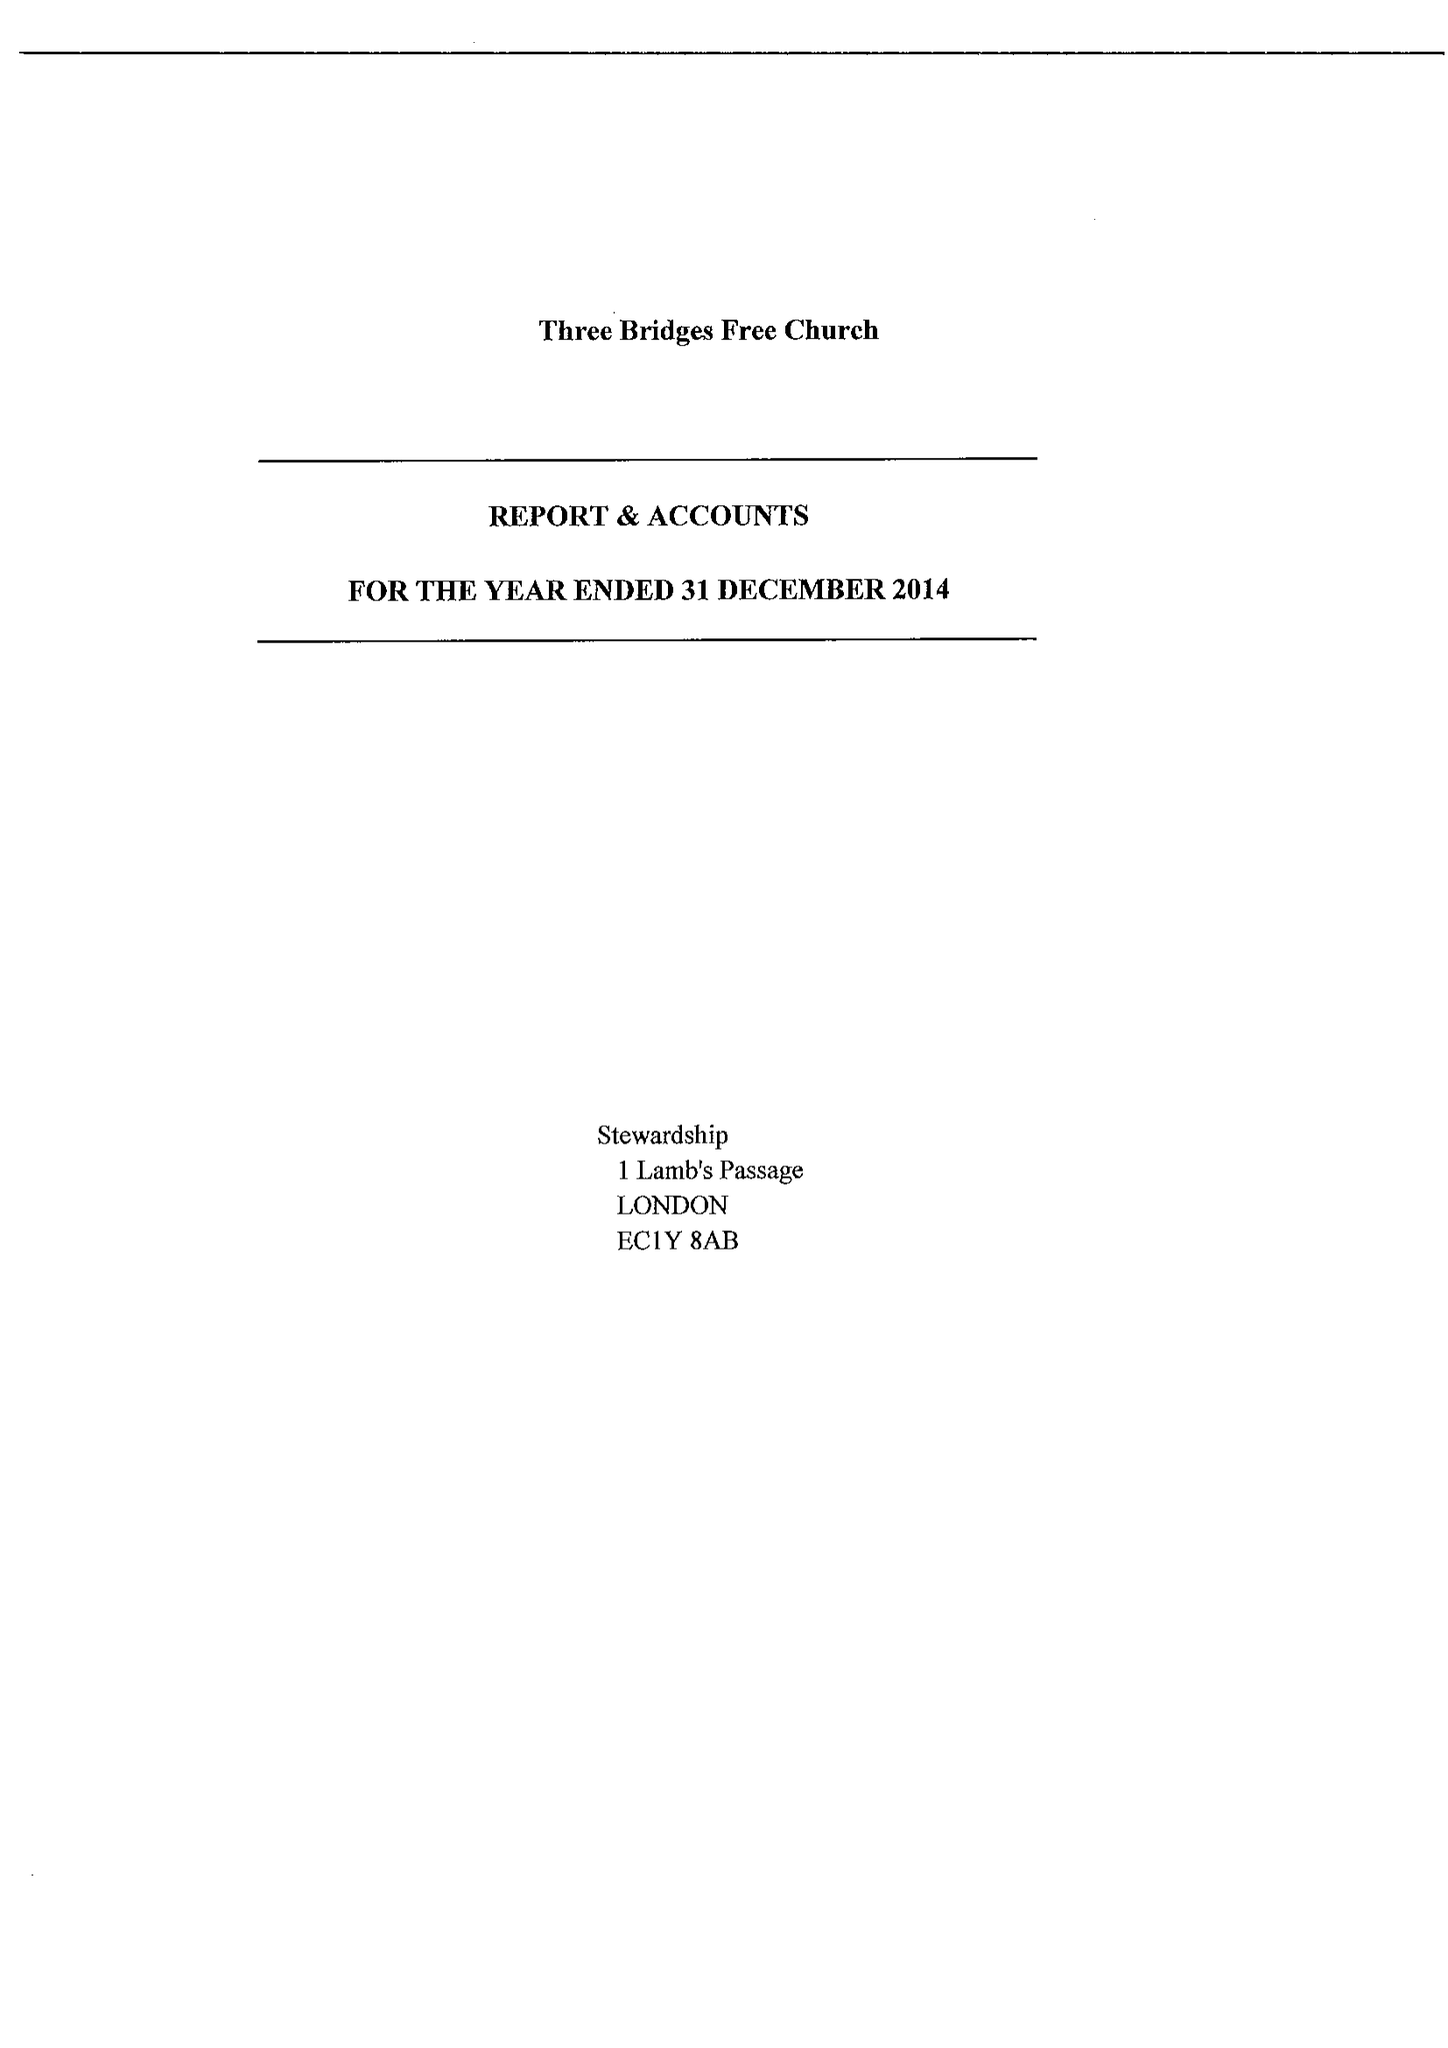What is the value for the charity_name?
Answer the question using a single word or phrase. Three Bridges Free Church 